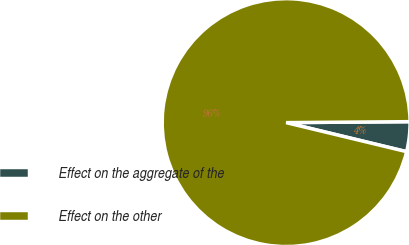Convert chart. <chart><loc_0><loc_0><loc_500><loc_500><pie_chart><fcel>Effect on the aggregate of the<fcel>Effect on the other<nl><fcel>3.89%<fcel>96.11%<nl></chart> 